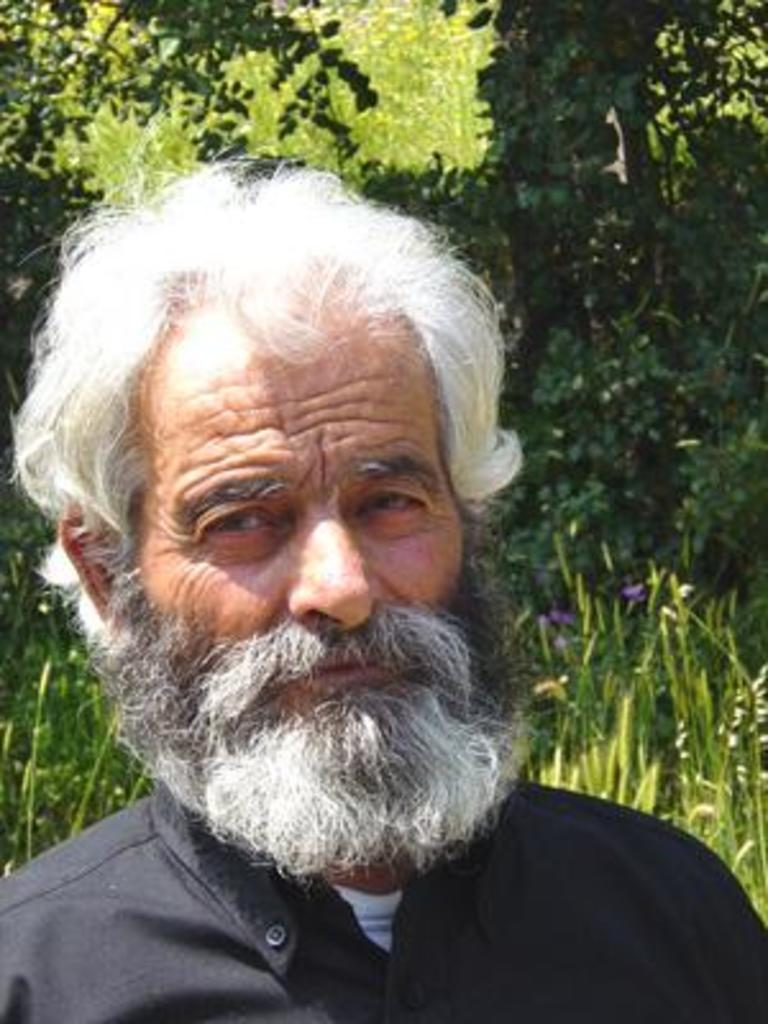Who is the main subject in the image? There is an old man in the image. What is the old man doing in the image? The old man is looking to one side. What can be seen in the background of the image? There are trees visible in the background of the image. What type of amusement can be seen in the image? There is no amusement present in the image; it features an old man looking to one side with trees in the background. 